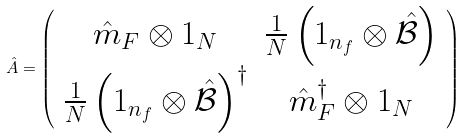<formula> <loc_0><loc_0><loc_500><loc_500>\hat { A } = \left ( \begin{array} { c c } \hat { m } _ { F } \otimes 1 _ { N } & \frac { 1 } { N } \left ( 1 _ { n _ { f } } \otimes \hat { \mathcal { B } } \right ) \\ \frac { 1 } { N } \left ( 1 _ { n _ { f } } \otimes \hat { \mathcal { B } } \right ) ^ { \dag } & \hat { m } ^ { \dag } _ { F } \otimes 1 _ { N } \end{array} \right )</formula> 